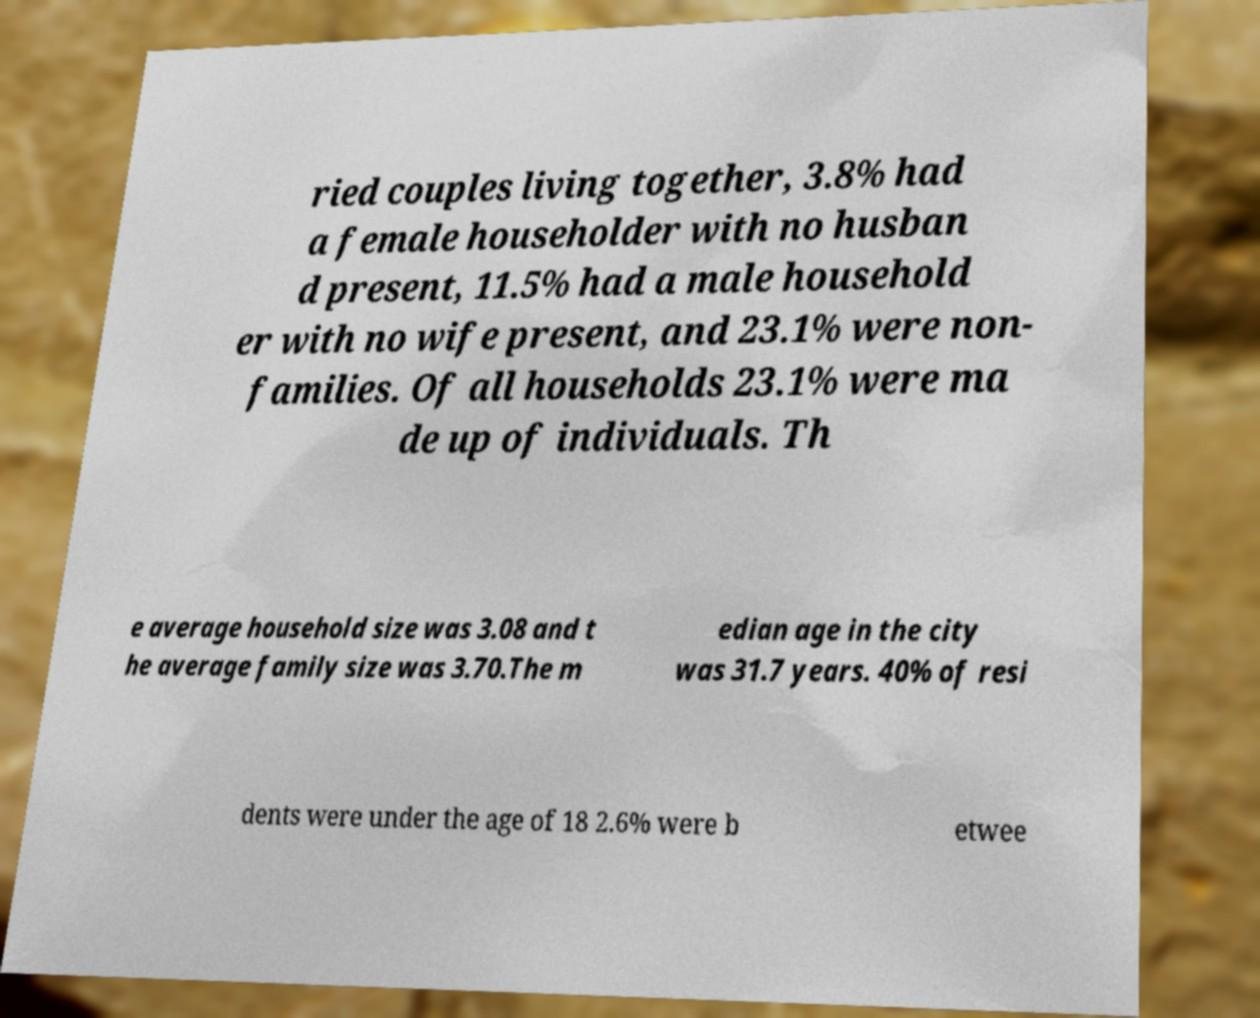Can you accurately transcribe the text from the provided image for me? ried couples living together, 3.8% had a female householder with no husban d present, 11.5% had a male household er with no wife present, and 23.1% were non- families. Of all households 23.1% were ma de up of individuals. Th e average household size was 3.08 and t he average family size was 3.70.The m edian age in the city was 31.7 years. 40% of resi dents were under the age of 18 2.6% were b etwee 